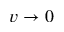<formula> <loc_0><loc_0><loc_500><loc_500>v \rightarrow 0</formula> 